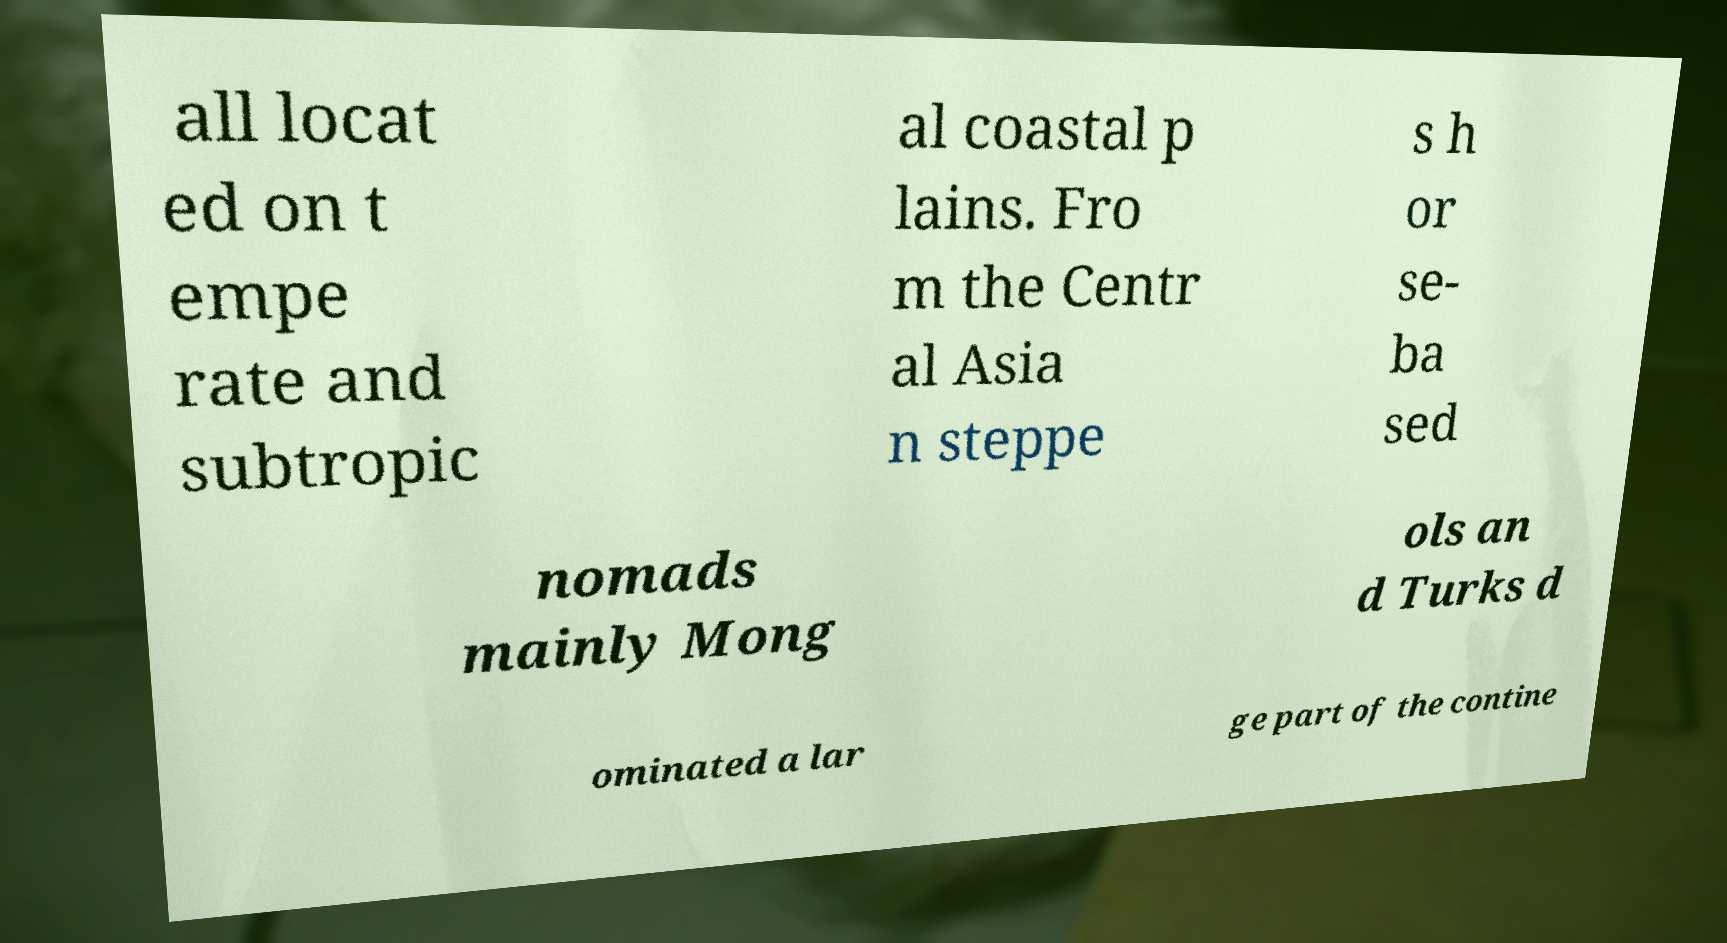Could you extract and type out the text from this image? all locat ed on t empe rate and subtropic al coastal p lains. Fro m the Centr al Asia n steppe s h or se- ba sed nomads mainly Mong ols an d Turks d ominated a lar ge part of the contine 